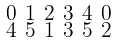Convert formula to latex. <formula><loc_0><loc_0><loc_500><loc_500>\begin{smallmatrix} 0 & 1 & 2 & 3 & 4 & 0 \\ 4 & 5 & 1 & 3 & 5 & 2 \end{smallmatrix}</formula> 